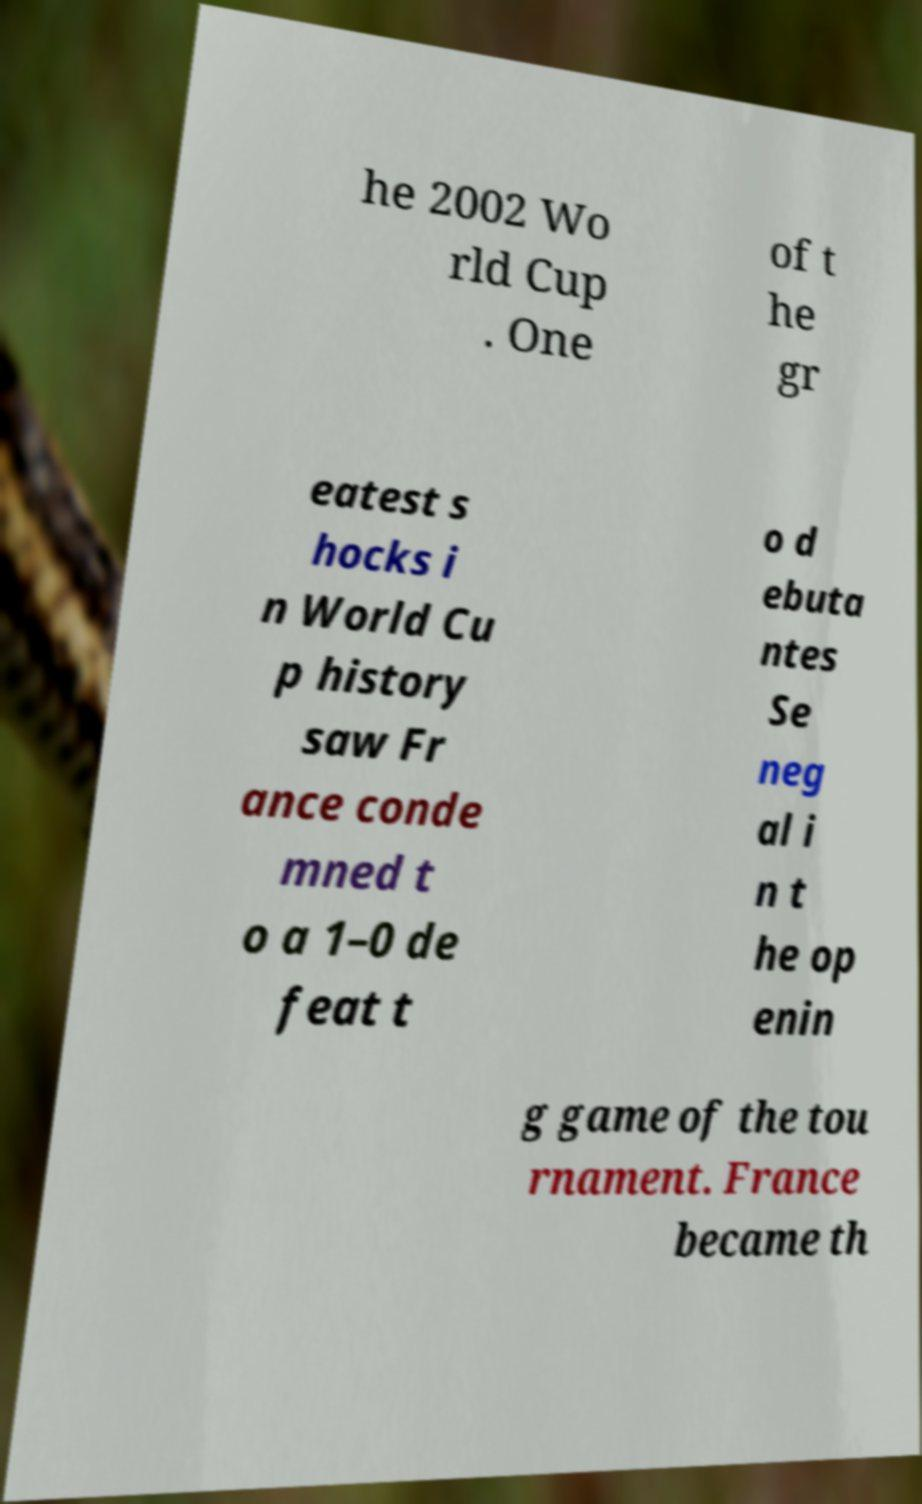I need the written content from this picture converted into text. Can you do that? he 2002 Wo rld Cup . One of t he gr eatest s hocks i n World Cu p history saw Fr ance conde mned t o a 1–0 de feat t o d ebuta ntes Se neg al i n t he op enin g game of the tou rnament. France became th 